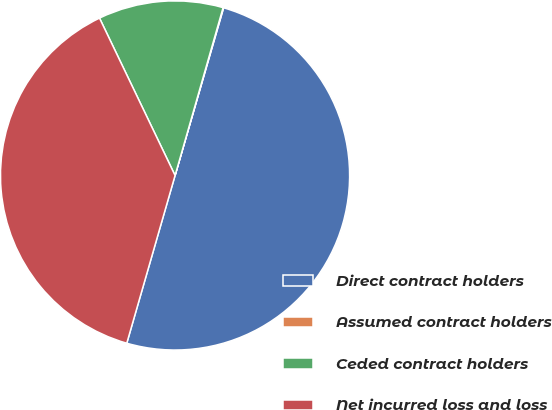Convert chart. <chart><loc_0><loc_0><loc_500><loc_500><pie_chart><fcel>Direct contract holders<fcel>Assumed contract holders<fcel>Ceded contract holders<fcel>Net incurred loss and loss<nl><fcel>49.98%<fcel>0.05%<fcel>11.56%<fcel>38.42%<nl></chart> 